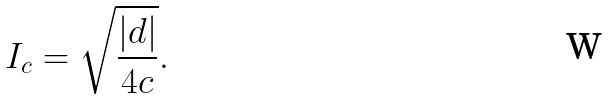<formula> <loc_0><loc_0><loc_500><loc_500>I _ { c } = \sqrt { \frac { | d | } { 4 c } } .</formula> 